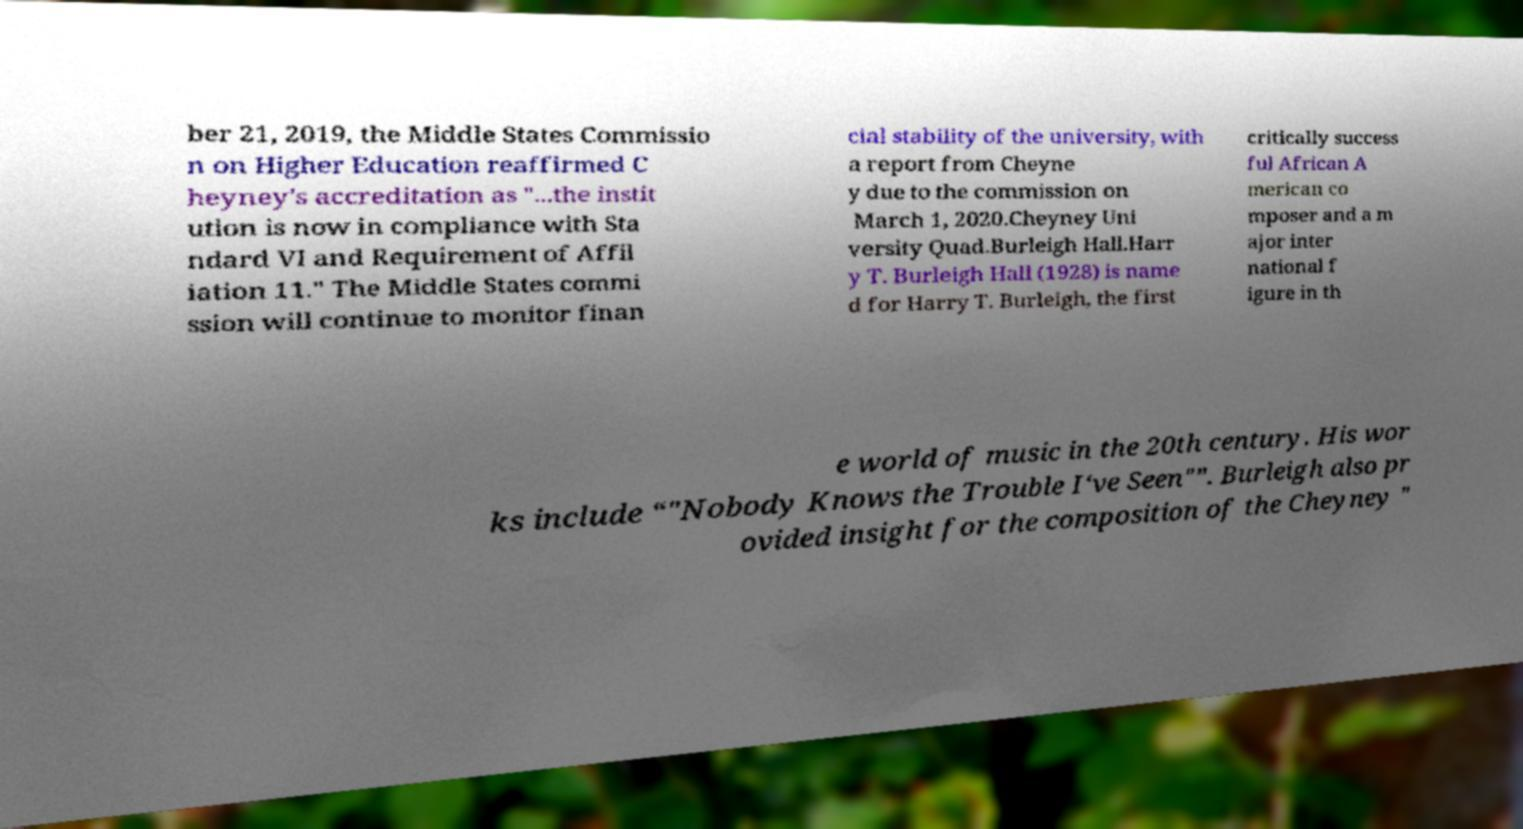Please identify and transcribe the text found in this image. ber 21, 2019, the Middle States Commissio n on Higher Education reaffirmed C heyney's accreditation as "...the instit ution is now in compliance with Sta ndard VI and Requirement of Affil iation 11." The Middle States commi ssion will continue to monitor finan cial stability of the university, with a report from Cheyne y due to the commission on March 1, 2020.Cheyney Uni versity Quad.Burleigh Hall.Harr y T. Burleigh Hall (1928) is name d for Harry T. Burleigh, the first critically success ful African A merican co mposer and a m ajor inter national f igure in th e world of music in the 20th century. His wor ks include “"Nobody Knows the Trouble I‘ve Seen"”. Burleigh also pr ovided insight for the composition of the Cheyney " 